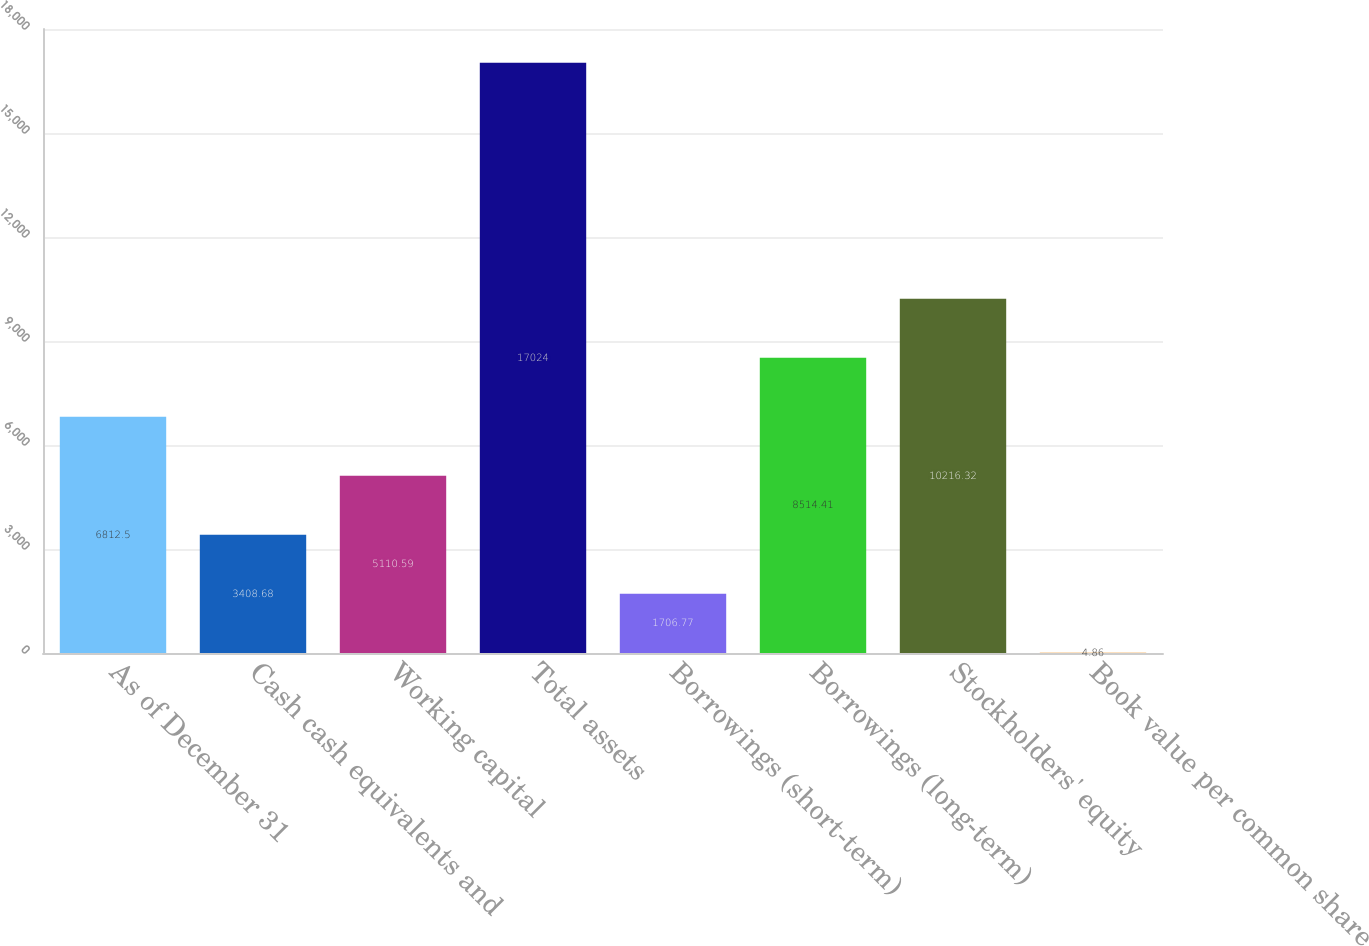Convert chart to OTSL. <chart><loc_0><loc_0><loc_500><loc_500><bar_chart><fcel>As of December 31<fcel>Cash cash equivalents and<fcel>Working capital<fcel>Total assets<fcel>Borrowings (short-term)<fcel>Borrowings (long-term)<fcel>Stockholders' equity<fcel>Book value per common share<nl><fcel>6812.5<fcel>3408.68<fcel>5110.59<fcel>17024<fcel>1706.77<fcel>8514.41<fcel>10216.3<fcel>4.86<nl></chart> 